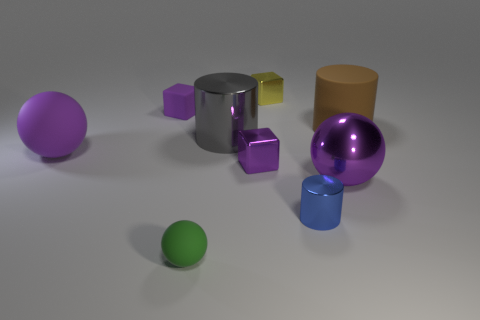Are there the same number of blue shiny things on the right side of the blue cylinder and brown shiny cylinders?
Provide a succinct answer. Yes. What is the size of the other purple object that is the same shape as the tiny purple rubber object?
Give a very brief answer. Small. Does the big gray thing have the same shape as the rubber thing behind the brown rubber cylinder?
Keep it short and to the point. No. There is a purple cube that is in front of the purple matte thing that is behind the large gray metal cylinder; how big is it?
Your answer should be compact. Small. Are there the same number of shiny spheres to the left of the small purple metallic thing and big purple balls to the left of the big purple matte sphere?
Make the answer very short. Yes. There is a matte object that is the same shape as the blue metallic object; what color is it?
Offer a terse response. Brown. How many big shiny objects have the same color as the small rubber block?
Keep it short and to the point. 1. Do the purple matte object in front of the big brown rubber object and the tiny green object have the same shape?
Offer a terse response. Yes. There is a big gray object that is on the left side of the shiny block that is in front of the block that is on the left side of the tiny matte ball; what shape is it?
Your response must be concise. Cylinder. How big is the brown rubber cylinder?
Your answer should be compact. Large. 